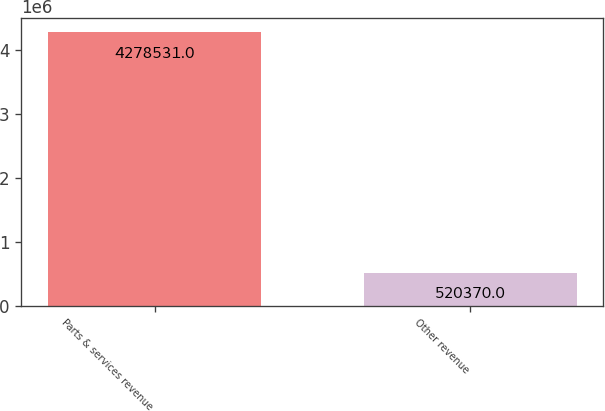Convert chart. <chart><loc_0><loc_0><loc_500><loc_500><bar_chart><fcel>Parts & services revenue<fcel>Other revenue<nl><fcel>4.27853e+06<fcel>520370<nl></chart> 